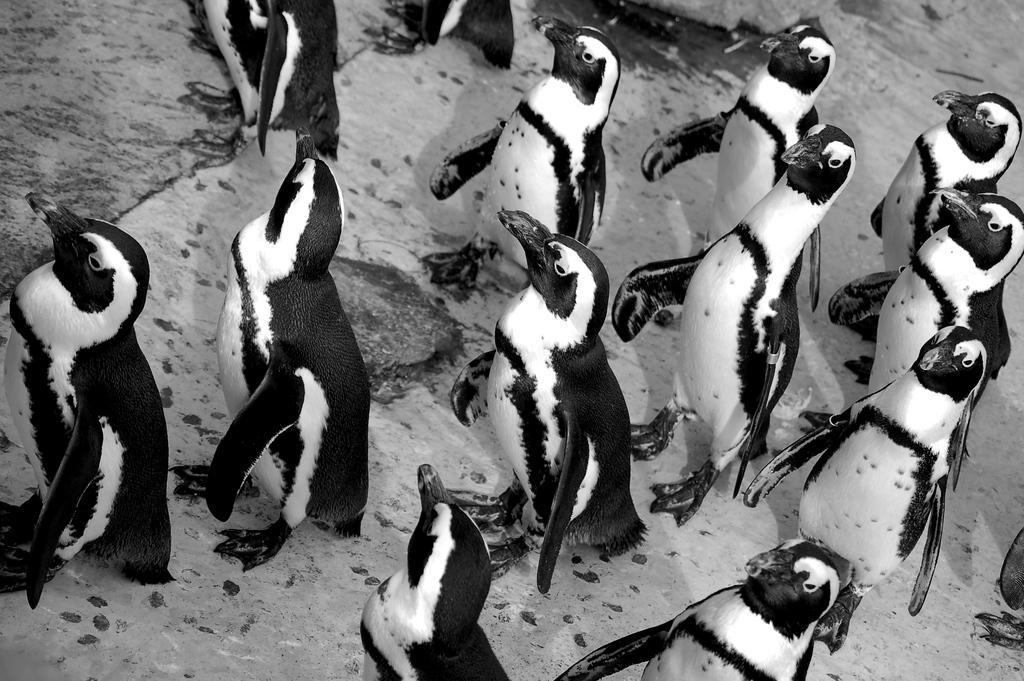What type of animals are present in the image? There are penguins in the image. Where are the penguins located? The penguins are on the surface. What type of authority do the penguins have in the image? The image does not depict any authority figures or situations, so it cannot be determined if the penguins have any authority. 